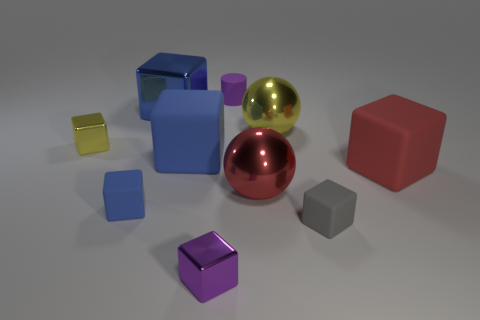There is a big metal cube; are there any tiny yellow objects to the right of it?
Ensure brevity in your answer.  No. What number of other things are there of the same size as the cylinder?
Provide a short and direct response. 4. There is a small object that is behind the large red cube and left of the purple rubber cylinder; what material is it?
Offer a very short reply. Metal. There is a blue object behind the big yellow thing; is it the same shape as the tiny object in front of the gray rubber object?
Your answer should be compact. Yes. Is there anything else that is the same material as the tiny yellow object?
Your answer should be very brief. Yes. There is a yellow metal object that is to the left of the small metal object in front of the big matte block that is to the left of the yellow ball; what is its shape?
Your answer should be very brief. Cube. How many other things are the same shape as the tiny gray object?
Your response must be concise. 6. What color is the matte cylinder that is the same size as the gray block?
Keep it short and to the point. Purple. What number of balls are either green rubber things or yellow shiny objects?
Provide a succinct answer. 1. What number of matte blocks are there?
Ensure brevity in your answer.  4. 